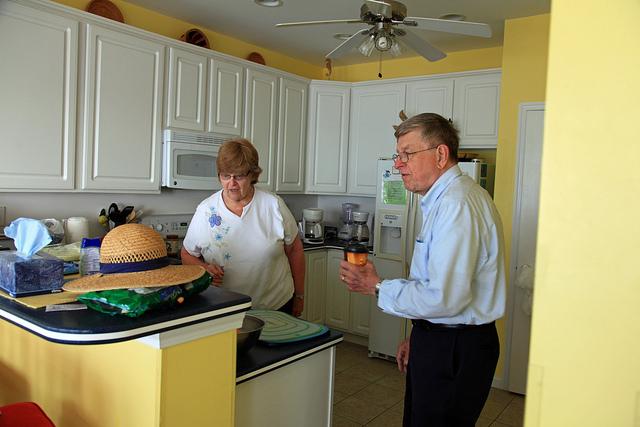Is this kitchen in a house?
Keep it brief. Yes. What shade of yellow is painted on the walls?
Write a very short answer. Pale. Is this man Amish?
Quick response, please. No. What room is the woman in?
Answer briefly. Kitchen. What colors are the walls?
Quick response, please. Yellow. How many girls are in this picture?
Quick response, please. 1. 